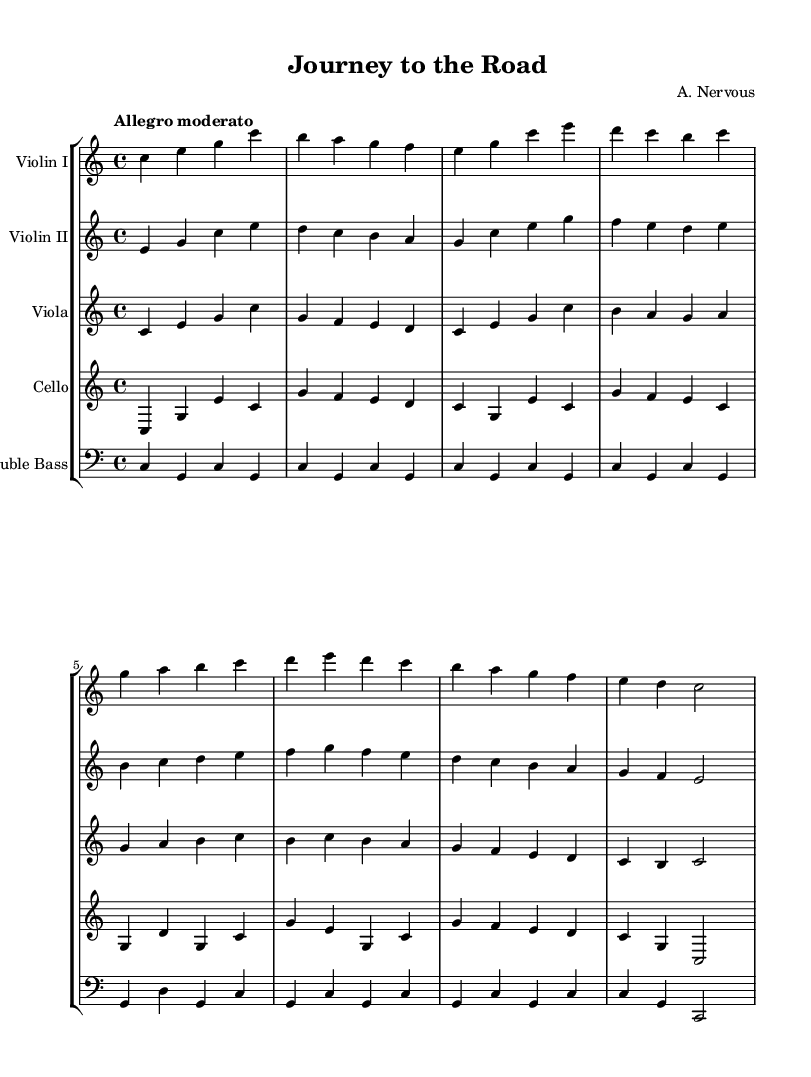What is the key signature of this music? The key signature shown in the music is C major, which is indicated by the absence of any sharps or flats. This can be verified by looking at the beginning of the staff where the key signature is normally placed.
Answer: C major What is the time signature of this music? The time signature indicated at the beginning of the sheet music is 4/4, which means there are four beats in each measure and the quarter note receives one beat. This information can be found directly after the key signature.
Answer: 4/4 What is the tempo marking for this piece? The tempo marking is "Allegro moderato," which indicates a moderately fast tempo suitable for uplifting music. This marking is usually placed above the staff at the start of the piece.
Answer: Allegro moderato How many measures are in the first violin part? The first violin part contains eight measures, confirmed by counting the measure lines in the specified section of the staff. Each measure is delineated by vertical lines.
Answer: 8 Which instruments are included in this score? The score includes Violin I, Violin II, Viola, Cello, and Double Bass, as each instrument is labeled at the beginning of its respective staff. This can be seen at the beginning of each individual staff.
Answer: Violin I, Violin II, Viola, Cello, Double Bass What is the rhythm pattern of the first four measures for the cello? The rhythm pattern for the cello in the first four measures consists of quarter notes in a steady rhythm, with occasional half notes. By examining the note values and their arrangement, we confirm the pattern.
Answer: Quarter notes and half notes What emotional theme does this symphony represent? The symphony represents a theme of overcoming challenges, as indicated by the title "Journey to the Road" and the uplifting tempo and harmonies from the music. This thematic element is often inferred from the title and musical style.
Answer: Overcoming challenges 